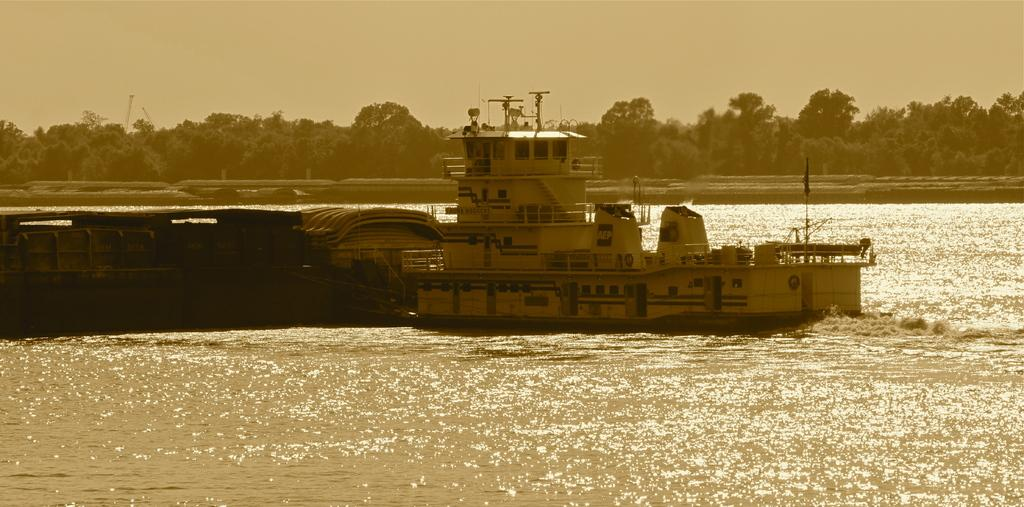What is the main subject of the image? The main subject of the image is a ship. Where is the ship located? The ship is on water. What else can be seen in the image besides the ship? There is a platform and trees visible in the image. What is visible in the background of the image? The sky is visible in the background of the image. Can you tell me how many pickles are on the platform in the image? There are no pickles present in the image; the platform is empty. What type of bird can be seen flying near the ship in the image? There is no bird visible in the image; only the ship, water, platform, trees, and sky are present. 